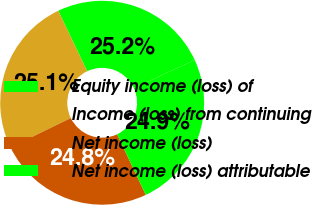Convert chart to OTSL. <chart><loc_0><loc_0><loc_500><loc_500><pie_chart><fcel>Equity income (loss) of<fcel>Income (loss) from continuing<fcel>Net income (loss)<fcel>Net income (loss) attributable<nl><fcel>25.19%<fcel>25.13%<fcel>24.82%<fcel>24.86%<nl></chart> 